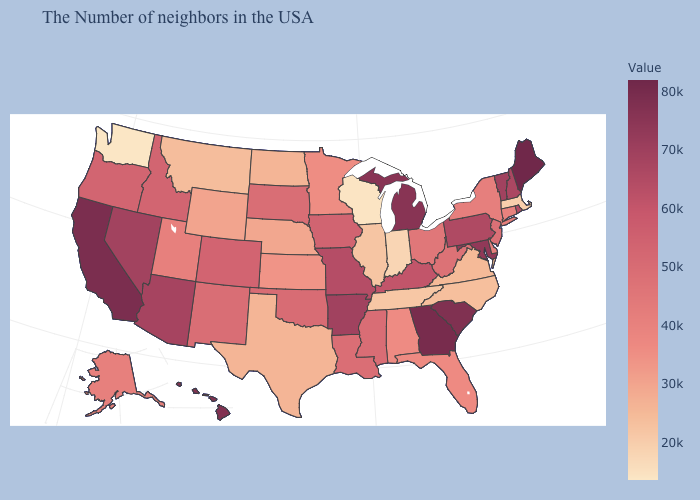Which states have the highest value in the USA?
Quick response, please. Maine. Does Maryland have a lower value than Maine?
Quick response, please. Yes. Is the legend a continuous bar?
Short answer required. Yes. Among the states that border Nebraska , which have the highest value?
Keep it brief. Missouri. Which states have the lowest value in the West?
Quick response, please. Washington. Among the states that border Vermont , does Massachusetts have the lowest value?
Answer briefly. Yes. Among the states that border Kentucky , does Indiana have the highest value?
Be succinct. No. Which states have the lowest value in the USA?
Write a very short answer. Washington. Does Kentucky have the highest value in the USA?
Write a very short answer. No. 